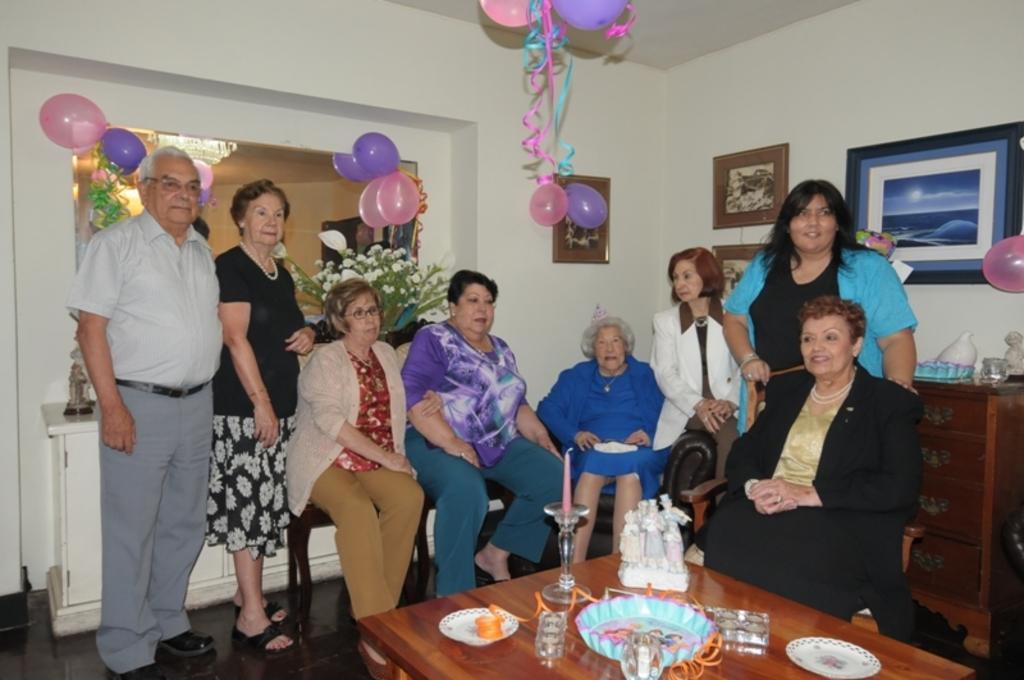Please provide a concise description of this image. There are group of people here in this room sitting and standing in front of the table. On the table we can see plate,glass,candle with stand. On the wall there are frames. And there is a table here there are also balloons hanging. 